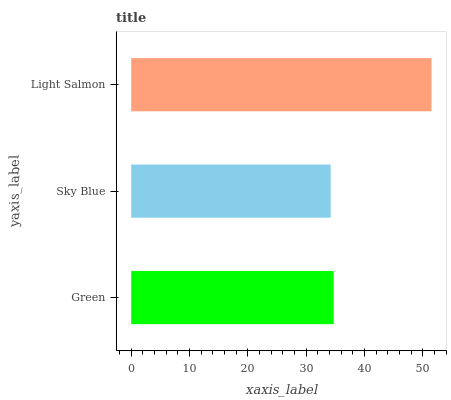Is Sky Blue the minimum?
Answer yes or no. Yes. Is Light Salmon the maximum?
Answer yes or no. Yes. Is Light Salmon the minimum?
Answer yes or no. No. Is Sky Blue the maximum?
Answer yes or no. No. Is Light Salmon greater than Sky Blue?
Answer yes or no. Yes. Is Sky Blue less than Light Salmon?
Answer yes or no. Yes. Is Sky Blue greater than Light Salmon?
Answer yes or no. No. Is Light Salmon less than Sky Blue?
Answer yes or no. No. Is Green the high median?
Answer yes or no. Yes. Is Green the low median?
Answer yes or no. Yes. Is Light Salmon the high median?
Answer yes or no. No. Is Sky Blue the low median?
Answer yes or no. No. 